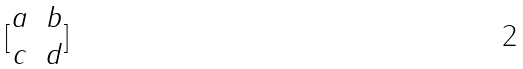Convert formula to latex. <formula><loc_0><loc_0><loc_500><loc_500>[ \begin{matrix} a & b \\ c & d \end{matrix} ]</formula> 